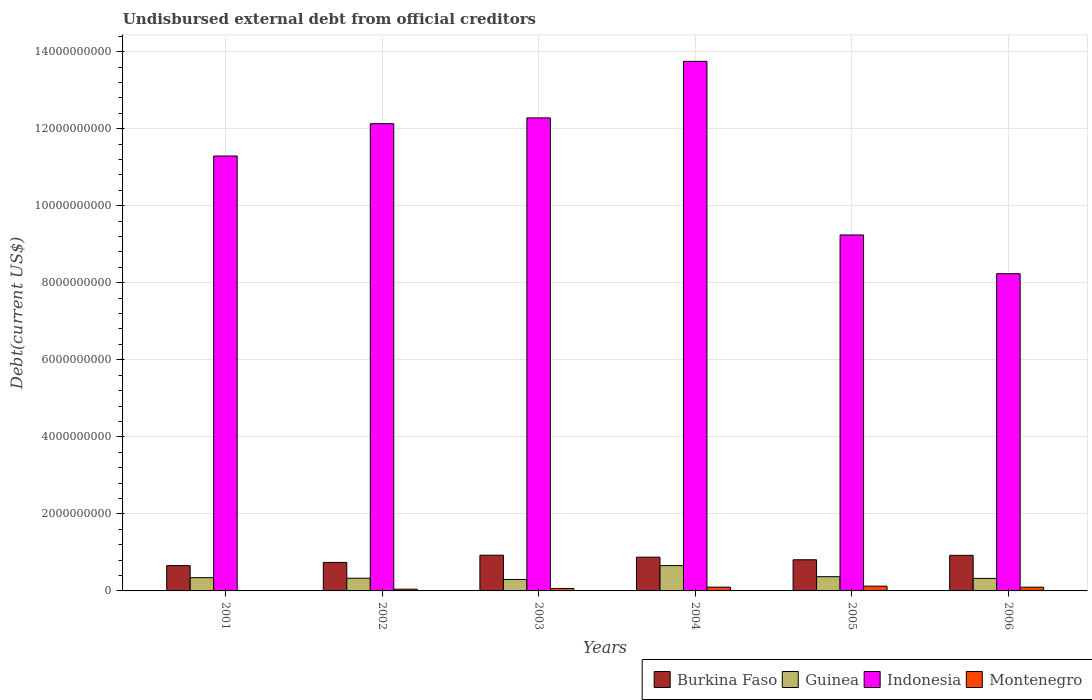How many groups of bars are there?
Provide a succinct answer. 6. How many bars are there on the 2nd tick from the left?
Your response must be concise. 4. What is the total debt in Montenegro in 2004?
Provide a succinct answer. 9.81e+07. Across all years, what is the maximum total debt in Guinea?
Keep it short and to the point. 6.57e+08. Across all years, what is the minimum total debt in Indonesia?
Offer a very short reply. 8.23e+09. What is the total total debt in Burkina Faso in the graph?
Provide a short and direct response. 4.93e+09. What is the difference between the total debt in Burkina Faso in 2003 and that in 2004?
Provide a succinct answer. 5.16e+07. What is the difference between the total debt in Montenegro in 2005 and the total debt in Indonesia in 2006?
Offer a terse response. -8.11e+09. What is the average total debt in Montenegro per year?
Ensure brevity in your answer.  7.28e+07. In the year 2001, what is the difference between the total debt in Montenegro and total debt in Burkina Faso?
Provide a succinct answer. -6.48e+08. In how many years, is the total debt in Indonesia greater than 1200000000 US$?
Your response must be concise. 6. What is the ratio of the total debt in Guinea in 2003 to that in 2006?
Give a very brief answer. 0.92. Is the total debt in Indonesia in 2002 less than that in 2006?
Offer a terse response. No. What is the difference between the highest and the second highest total debt in Montenegro?
Your response must be concise. 2.58e+07. What is the difference between the highest and the lowest total debt in Montenegro?
Offer a terse response. 1.15e+08. Is the sum of the total debt in Indonesia in 2003 and 2004 greater than the maximum total debt in Burkina Faso across all years?
Ensure brevity in your answer.  Yes. Is it the case that in every year, the sum of the total debt in Indonesia and total debt in Burkina Faso is greater than the sum of total debt in Guinea and total debt in Montenegro?
Offer a terse response. Yes. What does the 2nd bar from the left in 2005 represents?
Give a very brief answer. Guinea. Are all the bars in the graph horizontal?
Offer a terse response. No. How many years are there in the graph?
Provide a succinct answer. 6. What is the difference between two consecutive major ticks on the Y-axis?
Provide a succinct answer. 2.00e+09. Does the graph contain grids?
Keep it short and to the point. Yes. What is the title of the graph?
Provide a short and direct response. Undisbursed external debt from official creditors. What is the label or title of the Y-axis?
Provide a succinct answer. Debt(current US$). What is the Debt(current US$) of Burkina Faso in 2001?
Your answer should be very brief. 6.57e+08. What is the Debt(current US$) of Guinea in 2001?
Give a very brief answer. 3.44e+08. What is the Debt(current US$) of Indonesia in 2001?
Your answer should be compact. 1.13e+1. What is the Debt(current US$) of Montenegro in 2001?
Provide a short and direct response. 8.90e+06. What is the Debt(current US$) in Burkina Faso in 2002?
Provide a succinct answer. 7.40e+08. What is the Debt(current US$) of Guinea in 2002?
Ensure brevity in your answer.  3.30e+08. What is the Debt(current US$) of Indonesia in 2002?
Make the answer very short. 1.21e+1. What is the Debt(current US$) in Montenegro in 2002?
Your response must be concise. 4.53e+07. What is the Debt(current US$) of Burkina Faso in 2003?
Ensure brevity in your answer.  9.27e+08. What is the Debt(current US$) in Guinea in 2003?
Ensure brevity in your answer.  2.98e+08. What is the Debt(current US$) in Indonesia in 2003?
Your answer should be very brief. 1.23e+1. What is the Debt(current US$) of Montenegro in 2003?
Your response must be concise. 6.38e+07. What is the Debt(current US$) in Burkina Faso in 2004?
Give a very brief answer. 8.76e+08. What is the Debt(current US$) in Guinea in 2004?
Provide a short and direct response. 6.57e+08. What is the Debt(current US$) of Indonesia in 2004?
Your answer should be compact. 1.37e+1. What is the Debt(current US$) in Montenegro in 2004?
Your response must be concise. 9.81e+07. What is the Debt(current US$) of Burkina Faso in 2005?
Offer a very short reply. 8.08e+08. What is the Debt(current US$) in Guinea in 2005?
Offer a terse response. 3.70e+08. What is the Debt(current US$) in Indonesia in 2005?
Offer a very short reply. 9.24e+09. What is the Debt(current US$) in Montenegro in 2005?
Make the answer very short. 1.24e+08. What is the Debt(current US$) of Burkina Faso in 2006?
Provide a succinct answer. 9.24e+08. What is the Debt(current US$) in Guinea in 2006?
Offer a very short reply. 3.25e+08. What is the Debt(current US$) in Indonesia in 2006?
Your answer should be compact. 8.23e+09. What is the Debt(current US$) of Montenegro in 2006?
Ensure brevity in your answer.  9.70e+07. Across all years, what is the maximum Debt(current US$) of Burkina Faso?
Provide a short and direct response. 9.27e+08. Across all years, what is the maximum Debt(current US$) of Guinea?
Your answer should be compact. 6.57e+08. Across all years, what is the maximum Debt(current US$) of Indonesia?
Ensure brevity in your answer.  1.37e+1. Across all years, what is the maximum Debt(current US$) in Montenegro?
Offer a very short reply. 1.24e+08. Across all years, what is the minimum Debt(current US$) in Burkina Faso?
Provide a short and direct response. 6.57e+08. Across all years, what is the minimum Debt(current US$) of Guinea?
Keep it short and to the point. 2.98e+08. Across all years, what is the minimum Debt(current US$) of Indonesia?
Make the answer very short. 8.23e+09. Across all years, what is the minimum Debt(current US$) of Montenegro?
Make the answer very short. 8.90e+06. What is the total Debt(current US$) of Burkina Faso in the graph?
Keep it short and to the point. 4.93e+09. What is the total Debt(current US$) of Guinea in the graph?
Your answer should be very brief. 2.32e+09. What is the total Debt(current US$) in Indonesia in the graph?
Give a very brief answer. 6.69e+1. What is the total Debt(current US$) in Montenegro in the graph?
Make the answer very short. 4.37e+08. What is the difference between the Debt(current US$) of Burkina Faso in 2001 and that in 2002?
Ensure brevity in your answer.  -8.28e+07. What is the difference between the Debt(current US$) in Guinea in 2001 and that in 2002?
Make the answer very short. 1.46e+07. What is the difference between the Debt(current US$) in Indonesia in 2001 and that in 2002?
Offer a terse response. -8.39e+08. What is the difference between the Debt(current US$) in Montenegro in 2001 and that in 2002?
Keep it short and to the point. -3.64e+07. What is the difference between the Debt(current US$) in Burkina Faso in 2001 and that in 2003?
Your answer should be compact. -2.71e+08. What is the difference between the Debt(current US$) in Guinea in 2001 and that in 2003?
Your answer should be very brief. 4.65e+07. What is the difference between the Debt(current US$) in Indonesia in 2001 and that in 2003?
Give a very brief answer. -9.89e+08. What is the difference between the Debt(current US$) of Montenegro in 2001 and that in 2003?
Your answer should be compact. -5.49e+07. What is the difference between the Debt(current US$) in Burkina Faso in 2001 and that in 2004?
Your response must be concise. -2.19e+08. What is the difference between the Debt(current US$) in Guinea in 2001 and that in 2004?
Provide a short and direct response. -3.13e+08. What is the difference between the Debt(current US$) in Indonesia in 2001 and that in 2004?
Offer a very short reply. -2.46e+09. What is the difference between the Debt(current US$) in Montenegro in 2001 and that in 2004?
Your answer should be compact. -8.92e+07. What is the difference between the Debt(current US$) of Burkina Faso in 2001 and that in 2005?
Give a very brief answer. -1.52e+08. What is the difference between the Debt(current US$) in Guinea in 2001 and that in 2005?
Offer a very short reply. -2.57e+07. What is the difference between the Debt(current US$) of Indonesia in 2001 and that in 2005?
Your answer should be compact. 2.05e+09. What is the difference between the Debt(current US$) in Montenegro in 2001 and that in 2005?
Provide a succinct answer. -1.15e+08. What is the difference between the Debt(current US$) in Burkina Faso in 2001 and that in 2006?
Offer a very short reply. -2.67e+08. What is the difference between the Debt(current US$) in Guinea in 2001 and that in 2006?
Provide a short and direct response. 1.91e+07. What is the difference between the Debt(current US$) in Indonesia in 2001 and that in 2006?
Your answer should be very brief. 3.06e+09. What is the difference between the Debt(current US$) of Montenegro in 2001 and that in 2006?
Offer a terse response. -8.81e+07. What is the difference between the Debt(current US$) of Burkina Faso in 2002 and that in 2003?
Provide a succinct answer. -1.88e+08. What is the difference between the Debt(current US$) in Guinea in 2002 and that in 2003?
Your answer should be compact. 3.19e+07. What is the difference between the Debt(current US$) of Indonesia in 2002 and that in 2003?
Your response must be concise. -1.50e+08. What is the difference between the Debt(current US$) of Montenegro in 2002 and that in 2003?
Your answer should be very brief. -1.85e+07. What is the difference between the Debt(current US$) in Burkina Faso in 2002 and that in 2004?
Offer a terse response. -1.36e+08. What is the difference between the Debt(current US$) in Guinea in 2002 and that in 2004?
Ensure brevity in your answer.  -3.27e+08. What is the difference between the Debt(current US$) in Indonesia in 2002 and that in 2004?
Your answer should be compact. -1.62e+09. What is the difference between the Debt(current US$) of Montenegro in 2002 and that in 2004?
Your answer should be compact. -5.28e+07. What is the difference between the Debt(current US$) in Burkina Faso in 2002 and that in 2005?
Make the answer very short. -6.89e+07. What is the difference between the Debt(current US$) of Guinea in 2002 and that in 2005?
Make the answer very short. -4.03e+07. What is the difference between the Debt(current US$) of Indonesia in 2002 and that in 2005?
Keep it short and to the point. 2.89e+09. What is the difference between the Debt(current US$) of Montenegro in 2002 and that in 2005?
Offer a terse response. -7.86e+07. What is the difference between the Debt(current US$) in Burkina Faso in 2002 and that in 2006?
Offer a very short reply. -1.84e+08. What is the difference between the Debt(current US$) of Guinea in 2002 and that in 2006?
Provide a short and direct response. 4.50e+06. What is the difference between the Debt(current US$) in Indonesia in 2002 and that in 2006?
Provide a short and direct response. 3.89e+09. What is the difference between the Debt(current US$) in Montenegro in 2002 and that in 2006?
Provide a short and direct response. -5.17e+07. What is the difference between the Debt(current US$) of Burkina Faso in 2003 and that in 2004?
Your response must be concise. 5.16e+07. What is the difference between the Debt(current US$) of Guinea in 2003 and that in 2004?
Make the answer very short. -3.59e+08. What is the difference between the Debt(current US$) of Indonesia in 2003 and that in 2004?
Provide a succinct answer. -1.47e+09. What is the difference between the Debt(current US$) of Montenegro in 2003 and that in 2004?
Offer a terse response. -3.43e+07. What is the difference between the Debt(current US$) of Burkina Faso in 2003 and that in 2005?
Give a very brief answer. 1.19e+08. What is the difference between the Debt(current US$) of Guinea in 2003 and that in 2005?
Give a very brief answer. -7.22e+07. What is the difference between the Debt(current US$) of Indonesia in 2003 and that in 2005?
Offer a terse response. 3.04e+09. What is the difference between the Debt(current US$) in Montenegro in 2003 and that in 2005?
Give a very brief answer. -6.01e+07. What is the difference between the Debt(current US$) of Burkina Faso in 2003 and that in 2006?
Offer a terse response. 3.61e+06. What is the difference between the Debt(current US$) in Guinea in 2003 and that in 2006?
Provide a short and direct response. -2.74e+07. What is the difference between the Debt(current US$) of Indonesia in 2003 and that in 2006?
Offer a very short reply. 4.04e+09. What is the difference between the Debt(current US$) in Montenegro in 2003 and that in 2006?
Give a very brief answer. -3.32e+07. What is the difference between the Debt(current US$) of Burkina Faso in 2004 and that in 2005?
Your answer should be very brief. 6.74e+07. What is the difference between the Debt(current US$) of Guinea in 2004 and that in 2005?
Keep it short and to the point. 2.87e+08. What is the difference between the Debt(current US$) of Indonesia in 2004 and that in 2005?
Your response must be concise. 4.51e+09. What is the difference between the Debt(current US$) in Montenegro in 2004 and that in 2005?
Keep it short and to the point. -2.58e+07. What is the difference between the Debt(current US$) of Burkina Faso in 2004 and that in 2006?
Keep it short and to the point. -4.80e+07. What is the difference between the Debt(current US$) of Guinea in 2004 and that in 2006?
Keep it short and to the point. 3.32e+08. What is the difference between the Debt(current US$) of Indonesia in 2004 and that in 2006?
Provide a short and direct response. 5.51e+09. What is the difference between the Debt(current US$) of Montenegro in 2004 and that in 2006?
Provide a succinct answer. 1.08e+06. What is the difference between the Debt(current US$) of Burkina Faso in 2005 and that in 2006?
Provide a succinct answer. -1.15e+08. What is the difference between the Debt(current US$) in Guinea in 2005 and that in 2006?
Your answer should be compact. 4.48e+07. What is the difference between the Debt(current US$) of Indonesia in 2005 and that in 2006?
Ensure brevity in your answer.  1.01e+09. What is the difference between the Debt(current US$) of Montenegro in 2005 and that in 2006?
Ensure brevity in your answer.  2.69e+07. What is the difference between the Debt(current US$) of Burkina Faso in 2001 and the Debt(current US$) of Guinea in 2002?
Your answer should be very brief. 3.27e+08. What is the difference between the Debt(current US$) in Burkina Faso in 2001 and the Debt(current US$) in Indonesia in 2002?
Your answer should be compact. -1.15e+1. What is the difference between the Debt(current US$) of Burkina Faso in 2001 and the Debt(current US$) of Montenegro in 2002?
Give a very brief answer. 6.11e+08. What is the difference between the Debt(current US$) in Guinea in 2001 and the Debt(current US$) in Indonesia in 2002?
Keep it short and to the point. -1.18e+1. What is the difference between the Debt(current US$) in Guinea in 2001 and the Debt(current US$) in Montenegro in 2002?
Offer a terse response. 2.99e+08. What is the difference between the Debt(current US$) in Indonesia in 2001 and the Debt(current US$) in Montenegro in 2002?
Offer a very short reply. 1.12e+1. What is the difference between the Debt(current US$) in Burkina Faso in 2001 and the Debt(current US$) in Guinea in 2003?
Offer a very short reply. 3.59e+08. What is the difference between the Debt(current US$) in Burkina Faso in 2001 and the Debt(current US$) in Indonesia in 2003?
Make the answer very short. -1.16e+1. What is the difference between the Debt(current US$) of Burkina Faso in 2001 and the Debt(current US$) of Montenegro in 2003?
Provide a succinct answer. 5.93e+08. What is the difference between the Debt(current US$) of Guinea in 2001 and the Debt(current US$) of Indonesia in 2003?
Your answer should be compact. -1.19e+1. What is the difference between the Debt(current US$) in Guinea in 2001 and the Debt(current US$) in Montenegro in 2003?
Give a very brief answer. 2.80e+08. What is the difference between the Debt(current US$) of Indonesia in 2001 and the Debt(current US$) of Montenegro in 2003?
Offer a very short reply. 1.12e+1. What is the difference between the Debt(current US$) of Burkina Faso in 2001 and the Debt(current US$) of Guinea in 2004?
Give a very brief answer. -6.40e+04. What is the difference between the Debt(current US$) in Burkina Faso in 2001 and the Debt(current US$) in Indonesia in 2004?
Provide a short and direct response. -1.31e+1. What is the difference between the Debt(current US$) of Burkina Faso in 2001 and the Debt(current US$) of Montenegro in 2004?
Provide a succinct answer. 5.59e+08. What is the difference between the Debt(current US$) of Guinea in 2001 and the Debt(current US$) of Indonesia in 2004?
Your answer should be very brief. -1.34e+1. What is the difference between the Debt(current US$) of Guinea in 2001 and the Debt(current US$) of Montenegro in 2004?
Provide a succinct answer. 2.46e+08. What is the difference between the Debt(current US$) of Indonesia in 2001 and the Debt(current US$) of Montenegro in 2004?
Give a very brief answer. 1.12e+1. What is the difference between the Debt(current US$) of Burkina Faso in 2001 and the Debt(current US$) of Guinea in 2005?
Provide a short and direct response. 2.87e+08. What is the difference between the Debt(current US$) in Burkina Faso in 2001 and the Debt(current US$) in Indonesia in 2005?
Keep it short and to the point. -8.58e+09. What is the difference between the Debt(current US$) in Burkina Faso in 2001 and the Debt(current US$) in Montenegro in 2005?
Make the answer very short. 5.33e+08. What is the difference between the Debt(current US$) in Guinea in 2001 and the Debt(current US$) in Indonesia in 2005?
Provide a succinct answer. -8.90e+09. What is the difference between the Debt(current US$) of Guinea in 2001 and the Debt(current US$) of Montenegro in 2005?
Give a very brief answer. 2.20e+08. What is the difference between the Debt(current US$) in Indonesia in 2001 and the Debt(current US$) in Montenegro in 2005?
Give a very brief answer. 1.12e+1. What is the difference between the Debt(current US$) of Burkina Faso in 2001 and the Debt(current US$) of Guinea in 2006?
Make the answer very short. 3.32e+08. What is the difference between the Debt(current US$) in Burkina Faso in 2001 and the Debt(current US$) in Indonesia in 2006?
Provide a short and direct response. -7.58e+09. What is the difference between the Debt(current US$) of Burkina Faso in 2001 and the Debt(current US$) of Montenegro in 2006?
Your answer should be very brief. 5.60e+08. What is the difference between the Debt(current US$) in Guinea in 2001 and the Debt(current US$) in Indonesia in 2006?
Your answer should be compact. -7.89e+09. What is the difference between the Debt(current US$) of Guinea in 2001 and the Debt(current US$) of Montenegro in 2006?
Offer a terse response. 2.47e+08. What is the difference between the Debt(current US$) of Indonesia in 2001 and the Debt(current US$) of Montenegro in 2006?
Offer a terse response. 1.12e+1. What is the difference between the Debt(current US$) in Burkina Faso in 2002 and the Debt(current US$) in Guinea in 2003?
Provide a succinct answer. 4.42e+08. What is the difference between the Debt(current US$) in Burkina Faso in 2002 and the Debt(current US$) in Indonesia in 2003?
Keep it short and to the point. -1.15e+1. What is the difference between the Debt(current US$) in Burkina Faso in 2002 and the Debt(current US$) in Montenegro in 2003?
Offer a terse response. 6.76e+08. What is the difference between the Debt(current US$) of Guinea in 2002 and the Debt(current US$) of Indonesia in 2003?
Provide a short and direct response. -1.19e+1. What is the difference between the Debt(current US$) of Guinea in 2002 and the Debt(current US$) of Montenegro in 2003?
Your answer should be very brief. 2.66e+08. What is the difference between the Debt(current US$) in Indonesia in 2002 and the Debt(current US$) in Montenegro in 2003?
Offer a terse response. 1.21e+1. What is the difference between the Debt(current US$) in Burkina Faso in 2002 and the Debt(current US$) in Guinea in 2004?
Provide a short and direct response. 8.27e+07. What is the difference between the Debt(current US$) in Burkina Faso in 2002 and the Debt(current US$) in Indonesia in 2004?
Give a very brief answer. -1.30e+1. What is the difference between the Debt(current US$) in Burkina Faso in 2002 and the Debt(current US$) in Montenegro in 2004?
Provide a succinct answer. 6.41e+08. What is the difference between the Debt(current US$) in Guinea in 2002 and the Debt(current US$) in Indonesia in 2004?
Your answer should be compact. -1.34e+1. What is the difference between the Debt(current US$) of Guinea in 2002 and the Debt(current US$) of Montenegro in 2004?
Your answer should be very brief. 2.31e+08. What is the difference between the Debt(current US$) of Indonesia in 2002 and the Debt(current US$) of Montenegro in 2004?
Offer a terse response. 1.20e+1. What is the difference between the Debt(current US$) in Burkina Faso in 2002 and the Debt(current US$) in Guinea in 2005?
Ensure brevity in your answer.  3.70e+08. What is the difference between the Debt(current US$) of Burkina Faso in 2002 and the Debt(current US$) of Indonesia in 2005?
Offer a terse response. -8.50e+09. What is the difference between the Debt(current US$) in Burkina Faso in 2002 and the Debt(current US$) in Montenegro in 2005?
Make the answer very short. 6.16e+08. What is the difference between the Debt(current US$) of Guinea in 2002 and the Debt(current US$) of Indonesia in 2005?
Offer a terse response. -8.91e+09. What is the difference between the Debt(current US$) of Guinea in 2002 and the Debt(current US$) of Montenegro in 2005?
Your response must be concise. 2.06e+08. What is the difference between the Debt(current US$) in Indonesia in 2002 and the Debt(current US$) in Montenegro in 2005?
Your answer should be very brief. 1.20e+1. What is the difference between the Debt(current US$) of Burkina Faso in 2002 and the Debt(current US$) of Guinea in 2006?
Your answer should be compact. 4.14e+08. What is the difference between the Debt(current US$) in Burkina Faso in 2002 and the Debt(current US$) in Indonesia in 2006?
Make the answer very short. -7.50e+09. What is the difference between the Debt(current US$) of Burkina Faso in 2002 and the Debt(current US$) of Montenegro in 2006?
Provide a succinct answer. 6.43e+08. What is the difference between the Debt(current US$) in Guinea in 2002 and the Debt(current US$) in Indonesia in 2006?
Your response must be concise. -7.91e+09. What is the difference between the Debt(current US$) in Guinea in 2002 and the Debt(current US$) in Montenegro in 2006?
Give a very brief answer. 2.33e+08. What is the difference between the Debt(current US$) of Indonesia in 2002 and the Debt(current US$) of Montenegro in 2006?
Keep it short and to the point. 1.20e+1. What is the difference between the Debt(current US$) of Burkina Faso in 2003 and the Debt(current US$) of Guinea in 2004?
Make the answer very short. 2.71e+08. What is the difference between the Debt(current US$) in Burkina Faso in 2003 and the Debt(current US$) in Indonesia in 2004?
Offer a terse response. -1.28e+1. What is the difference between the Debt(current US$) in Burkina Faso in 2003 and the Debt(current US$) in Montenegro in 2004?
Offer a very short reply. 8.29e+08. What is the difference between the Debt(current US$) of Guinea in 2003 and the Debt(current US$) of Indonesia in 2004?
Provide a short and direct response. -1.34e+1. What is the difference between the Debt(current US$) in Guinea in 2003 and the Debt(current US$) in Montenegro in 2004?
Offer a very short reply. 2.00e+08. What is the difference between the Debt(current US$) in Indonesia in 2003 and the Debt(current US$) in Montenegro in 2004?
Make the answer very short. 1.22e+1. What is the difference between the Debt(current US$) of Burkina Faso in 2003 and the Debt(current US$) of Guinea in 2005?
Give a very brief answer. 5.58e+08. What is the difference between the Debt(current US$) in Burkina Faso in 2003 and the Debt(current US$) in Indonesia in 2005?
Offer a terse response. -8.31e+09. What is the difference between the Debt(current US$) in Burkina Faso in 2003 and the Debt(current US$) in Montenegro in 2005?
Your response must be concise. 8.04e+08. What is the difference between the Debt(current US$) of Guinea in 2003 and the Debt(current US$) of Indonesia in 2005?
Offer a very short reply. -8.94e+09. What is the difference between the Debt(current US$) of Guinea in 2003 and the Debt(current US$) of Montenegro in 2005?
Offer a terse response. 1.74e+08. What is the difference between the Debt(current US$) in Indonesia in 2003 and the Debt(current US$) in Montenegro in 2005?
Keep it short and to the point. 1.22e+1. What is the difference between the Debt(current US$) in Burkina Faso in 2003 and the Debt(current US$) in Guinea in 2006?
Keep it short and to the point. 6.02e+08. What is the difference between the Debt(current US$) in Burkina Faso in 2003 and the Debt(current US$) in Indonesia in 2006?
Provide a succinct answer. -7.31e+09. What is the difference between the Debt(current US$) in Burkina Faso in 2003 and the Debt(current US$) in Montenegro in 2006?
Give a very brief answer. 8.30e+08. What is the difference between the Debt(current US$) of Guinea in 2003 and the Debt(current US$) of Indonesia in 2006?
Your answer should be compact. -7.94e+09. What is the difference between the Debt(current US$) in Guinea in 2003 and the Debt(current US$) in Montenegro in 2006?
Your response must be concise. 2.01e+08. What is the difference between the Debt(current US$) in Indonesia in 2003 and the Debt(current US$) in Montenegro in 2006?
Offer a very short reply. 1.22e+1. What is the difference between the Debt(current US$) of Burkina Faso in 2004 and the Debt(current US$) of Guinea in 2005?
Ensure brevity in your answer.  5.06e+08. What is the difference between the Debt(current US$) in Burkina Faso in 2004 and the Debt(current US$) in Indonesia in 2005?
Keep it short and to the point. -8.36e+09. What is the difference between the Debt(current US$) of Burkina Faso in 2004 and the Debt(current US$) of Montenegro in 2005?
Give a very brief answer. 7.52e+08. What is the difference between the Debt(current US$) in Guinea in 2004 and the Debt(current US$) in Indonesia in 2005?
Keep it short and to the point. -8.58e+09. What is the difference between the Debt(current US$) of Guinea in 2004 and the Debt(current US$) of Montenegro in 2005?
Provide a succinct answer. 5.33e+08. What is the difference between the Debt(current US$) of Indonesia in 2004 and the Debt(current US$) of Montenegro in 2005?
Keep it short and to the point. 1.36e+1. What is the difference between the Debt(current US$) in Burkina Faso in 2004 and the Debt(current US$) in Guinea in 2006?
Your response must be concise. 5.51e+08. What is the difference between the Debt(current US$) of Burkina Faso in 2004 and the Debt(current US$) of Indonesia in 2006?
Ensure brevity in your answer.  -7.36e+09. What is the difference between the Debt(current US$) in Burkina Faso in 2004 and the Debt(current US$) in Montenegro in 2006?
Ensure brevity in your answer.  7.79e+08. What is the difference between the Debt(current US$) of Guinea in 2004 and the Debt(current US$) of Indonesia in 2006?
Offer a terse response. -7.58e+09. What is the difference between the Debt(current US$) in Guinea in 2004 and the Debt(current US$) in Montenegro in 2006?
Ensure brevity in your answer.  5.60e+08. What is the difference between the Debt(current US$) in Indonesia in 2004 and the Debt(current US$) in Montenegro in 2006?
Give a very brief answer. 1.36e+1. What is the difference between the Debt(current US$) in Burkina Faso in 2005 and the Debt(current US$) in Guinea in 2006?
Provide a short and direct response. 4.83e+08. What is the difference between the Debt(current US$) of Burkina Faso in 2005 and the Debt(current US$) of Indonesia in 2006?
Your answer should be very brief. -7.43e+09. What is the difference between the Debt(current US$) of Burkina Faso in 2005 and the Debt(current US$) of Montenegro in 2006?
Make the answer very short. 7.11e+08. What is the difference between the Debt(current US$) in Guinea in 2005 and the Debt(current US$) in Indonesia in 2006?
Provide a succinct answer. -7.86e+09. What is the difference between the Debt(current US$) in Guinea in 2005 and the Debt(current US$) in Montenegro in 2006?
Offer a terse response. 2.73e+08. What is the difference between the Debt(current US$) of Indonesia in 2005 and the Debt(current US$) of Montenegro in 2006?
Provide a succinct answer. 9.14e+09. What is the average Debt(current US$) of Burkina Faso per year?
Ensure brevity in your answer.  8.22e+08. What is the average Debt(current US$) in Guinea per year?
Your answer should be compact. 3.87e+08. What is the average Debt(current US$) of Indonesia per year?
Give a very brief answer. 1.12e+1. What is the average Debt(current US$) in Montenegro per year?
Offer a very short reply. 7.28e+07. In the year 2001, what is the difference between the Debt(current US$) in Burkina Faso and Debt(current US$) in Guinea?
Offer a very short reply. 3.13e+08. In the year 2001, what is the difference between the Debt(current US$) of Burkina Faso and Debt(current US$) of Indonesia?
Give a very brief answer. -1.06e+1. In the year 2001, what is the difference between the Debt(current US$) of Burkina Faso and Debt(current US$) of Montenegro?
Your answer should be compact. 6.48e+08. In the year 2001, what is the difference between the Debt(current US$) of Guinea and Debt(current US$) of Indonesia?
Provide a succinct answer. -1.09e+1. In the year 2001, what is the difference between the Debt(current US$) of Guinea and Debt(current US$) of Montenegro?
Provide a succinct answer. 3.35e+08. In the year 2001, what is the difference between the Debt(current US$) in Indonesia and Debt(current US$) in Montenegro?
Offer a very short reply. 1.13e+1. In the year 2002, what is the difference between the Debt(current US$) in Burkina Faso and Debt(current US$) in Guinea?
Make the answer very short. 4.10e+08. In the year 2002, what is the difference between the Debt(current US$) in Burkina Faso and Debt(current US$) in Indonesia?
Provide a short and direct response. -1.14e+1. In the year 2002, what is the difference between the Debt(current US$) of Burkina Faso and Debt(current US$) of Montenegro?
Provide a short and direct response. 6.94e+08. In the year 2002, what is the difference between the Debt(current US$) in Guinea and Debt(current US$) in Indonesia?
Offer a terse response. -1.18e+1. In the year 2002, what is the difference between the Debt(current US$) in Guinea and Debt(current US$) in Montenegro?
Offer a very short reply. 2.84e+08. In the year 2002, what is the difference between the Debt(current US$) of Indonesia and Debt(current US$) of Montenegro?
Give a very brief answer. 1.21e+1. In the year 2003, what is the difference between the Debt(current US$) of Burkina Faso and Debt(current US$) of Guinea?
Your answer should be very brief. 6.30e+08. In the year 2003, what is the difference between the Debt(current US$) of Burkina Faso and Debt(current US$) of Indonesia?
Give a very brief answer. -1.14e+1. In the year 2003, what is the difference between the Debt(current US$) of Burkina Faso and Debt(current US$) of Montenegro?
Your answer should be compact. 8.64e+08. In the year 2003, what is the difference between the Debt(current US$) in Guinea and Debt(current US$) in Indonesia?
Your answer should be very brief. -1.20e+1. In the year 2003, what is the difference between the Debt(current US$) in Guinea and Debt(current US$) in Montenegro?
Ensure brevity in your answer.  2.34e+08. In the year 2003, what is the difference between the Debt(current US$) of Indonesia and Debt(current US$) of Montenegro?
Keep it short and to the point. 1.22e+1. In the year 2004, what is the difference between the Debt(current US$) of Burkina Faso and Debt(current US$) of Guinea?
Give a very brief answer. 2.19e+08. In the year 2004, what is the difference between the Debt(current US$) of Burkina Faso and Debt(current US$) of Indonesia?
Offer a terse response. -1.29e+1. In the year 2004, what is the difference between the Debt(current US$) of Burkina Faso and Debt(current US$) of Montenegro?
Make the answer very short. 7.78e+08. In the year 2004, what is the difference between the Debt(current US$) in Guinea and Debt(current US$) in Indonesia?
Make the answer very short. -1.31e+1. In the year 2004, what is the difference between the Debt(current US$) in Guinea and Debt(current US$) in Montenegro?
Offer a very short reply. 5.59e+08. In the year 2004, what is the difference between the Debt(current US$) in Indonesia and Debt(current US$) in Montenegro?
Your answer should be very brief. 1.36e+1. In the year 2005, what is the difference between the Debt(current US$) of Burkina Faso and Debt(current US$) of Guinea?
Make the answer very short. 4.38e+08. In the year 2005, what is the difference between the Debt(current US$) of Burkina Faso and Debt(current US$) of Indonesia?
Your answer should be very brief. -8.43e+09. In the year 2005, what is the difference between the Debt(current US$) of Burkina Faso and Debt(current US$) of Montenegro?
Offer a very short reply. 6.84e+08. In the year 2005, what is the difference between the Debt(current US$) in Guinea and Debt(current US$) in Indonesia?
Offer a very short reply. -8.87e+09. In the year 2005, what is the difference between the Debt(current US$) in Guinea and Debt(current US$) in Montenegro?
Provide a short and direct response. 2.46e+08. In the year 2005, what is the difference between the Debt(current US$) of Indonesia and Debt(current US$) of Montenegro?
Your response must be concise. 9.12e+09. In the year 2006, what is the difference between the Debt(current US$) in Burkina Faso and Debt(current US$) in Guinea?
Give a very brief answer. 5.99e+08. In the year 2006, what is the difference between the Debt(current US$) in Burkina Faso and Debt(current US$) in Indonesia?
Make the answer very short. -7.31e+09. In the year 2006, what is the difference between the Debt(current US$) in Burkina Faso and Debt(current US$) in Montenegro?
Your response must be concise. 8.27e+08. In the year 2006, what is the difference between the Debt(current US$) in Guinea and Debt(current US$) in Indonesia?
Provide a short and direct response. -7.91e+09. In the year 2006, what is the difference between the Debt(current US$) in Guinea and Debt(current US$) in Montenegro?
Your answer should be very brief. 2.28e+08. In the year 2006, what is the difference between the Debt(current US$) in Indonesia and Debt(current US$) in Montenegro?
Provide a succinct answer. 8.14e+09. What is the ratio of the Debt(current US$) of Burkina Faso in 2001 to that in 2002?
Your answer should be very brief. 0.89. What is the ratio of the Debt(current US$) in Guinea in 2001 to that in 2002?
Your answer should be compact. 1.04. What is the ratio of the Debt(current US$) in Indonesia in 2001 to that in 2002?
Your response must be concise. 0.93. What is the ratio of the Debt(current US$) of Montenegro in 2001 to that in 2002?
Offer a terse response. 0.2. What is the ratio of the Debt(current US$) of Burkina Faso in 2001 to that in 2003?
Your response must be concise. 0.71. What is the ratio of the Debt(current US$) of Guinea in 2001 to that in 2003?
Your answer should be very brief. 1.16. What is the ratio of the Debt(current US$) of Indonesia in 2001 to that in 2003?
Your answer should be very brief. 0.92. What is the ratio of the Debt(current US$) of Montenegro in 2001 to that in 2003?
Your answer should be compact. 0.14. What is the ratio of the Debt(current US$) of Burkina Faso in 2001 to that in 2004?
Keep it short and to the point. 0.75. What is the ratio of the Debt(current US$) in Guinea in 2001 to that in 2004?
Provide a short and direct response. 0.52. What is the ratio of the Debt(current US$) of Indonesia in 2001 to that in 2004?
Your answer should be very brief. 0.82. What is the ratio of the Debt(current US$) of Montenegro in 2001 to that in 2004?
Provide a short and direct response. 0.09. What is the ratio of the Debt(current US$) in Burkina Faso in 2001 to that in 2005?
Give a very brief answer. 0.81. What is the ratio of the Debt(current US$) in Guinea in 2001 to that in 2005?
Keep it short and to the point. 0.93. What is the ratio of the Debt(current US$) in Indonesia in 2001 to that in 2005?
Give a very brief answer. 1.22. What is the ratio of the Debt(current US$) in Montenegro in 2001 to that in 2005?
Provide a short and direct response. 0.07. What is the ratio of the Debt(current US$) in Burkina Faso in 2001 to that in 2006?
Your answer should be very brief. 0.71. What is the ratio of the Debt(current US$) in Guinea in 2001 to that in 2006?
Provide a short and direct response. 1.06. What is the ratio of the Debt(current US$) in Indonesia in 2001 to that in 2006?
Your answer should be compact. 1.37. What is the ratio of the Debt(current US$) in Montenegro in 2001 to that in 2006?
Make the answer very short. 0.09. What is the ratio of the Debt(current US$) in Burkina Faso in 2002 to that in 2003?
Provide a succinct answer. 0.8. What is the ratio of the Debt(current US$) in Guinea in 2002 to that in 2003?
Your answer should be very brief. 1.11. What is the ratio of the Debt(current US$) in Indonesia in 2002 to that in 2003?
Keep it short and to the point. 0.99. What is the ratio of the Debt(current US$) in Montenegro in 2002 to that in 2003?
Offer a terse response. 0.71. What is the ratio of the Debt(current US$) in Burkina Faso in 2002 to that in 2004?
Your response must be concise. 0.84. What is the ratio of the Debt(current US$) in Guinea in 2002 to that in 2004?
Offer a terse response. 0.5. What is the ratio of the Debt(current US$) in Indonesia in 2002 to that in 2004?
Provide a succinct answer. 0.88. What is the ratio of the Debt(current US$) of Montenegro in 2002 to that in 2004?
Your answer should be very brief. 0.46. What is the ratio of the Debt(current US$) of Burkina Faso in 2002 to that in 2005?
Your answer should be very brief. 0.91. What is the ratio of the Debt(current US$) of Guinea in 2002 to that in 2005?
Your answer should be compact. 0.89. What is the ratio of the Debt(current US$) in Indonesia in 2002 to that in 2005?
Your response must be concise. 1.31. What is the ratio of the Debt(current US$) of Montenegro in 2002 to that in 2005?
Provide a short and direct response. 0.37. What is the ratio of the Debt(current US$) of Burkina Faso in 2002 to that in 2006?
Offer a very short reply. 0.8. What is the ratio of the Debt(current US$) of Guinea in 2002 to that in 2006?
Ensure brevity in your answer.  1.01. What is the ratio of the Debt(current US$) of Indonesia in 2002 to that in 2006?
Your answer should be very brief. 1.47. What is the ratio of the Debt(current US$) of Montenegro in 2002 to that in 2006?
Ensure brevity in your answer.  0.47. What is the ratio of the Debt(current US$) in Burkina Faso in 2003 to that in 2004?
Provide a short and direct response. 1.06. What is the ratio of the Debt(current US$) of Guinea in 2003 to that in 2004?
Offer a very short reply. 0.45. What is the ratio of the Debt(current US$) of Indonesia in 2003 to that in 2004?
Keep it short and to the point. 0.89. What is the ratio of the Debt(current US$) in Montenegro in 2003 to that in 2004?
Your answer should be very brief. 0.65. What is the ratio of the Debt(current US$) in Burkina Faso in 2003 to that in 2005?
Offer a terse response. 1.15. What is the ratio of the Debt(current US$) in Guinea in 2003 to that in 2005?
Provide a succinct answer. 0.8. What is the ratio of the Debt(current US$) of Indonesia in 2003 to that in 2005?
Keep it short and to the point. 1.33. What is the ratio of the Debt(current US$) of Montenegro in 2003 to that in 2005?
Provide a short and direct response. 0.51. What is the ratio of the Debt(current US$) in Burkina Faso in 2003 to that in 2006?
Offer a terse response. 1. What is the ratio of the Debt(current US$) in Guinea in 2003 to that in 2006?
Your answer should be compact. 0.92. What is the ratio of the Debt(current US$) of Indonesia in 2003 to that in 2006?
Offer a terse response. 1.49. What is the ratio of the Debt(current US$) of Montenegro in 2003 to that in 2006?
Ensure brevity in your answer.  0.66. What is the ratio of the Debt(current US$) in Burkina Faso in 2004 to that in 2005?
Give a very brief answer. 1.08. What is the ratio of the Debt(current US$) of Guinea in 2004 to that in 2005?
Offer a terse response. 1.78. What is the ratio of the Debt(current US$) in Indonesia in 2004 to that in 2005?
Offer a terse response. 1.49. What is the ratio of the Debt(current US$) of Montenegro in 2004 to that in 2005?
Your answer should be very brief. 0.79. What is the ratio of the Debt(current US$) in Burkina Faso in 2004 to that in 2006?
Offer a very short reply. 0.95. What is the ratio of the Debt(current US$) in Guinea in 2004 to that in 2006?
Provide a short and direct response. 2.02. What is the ratio of the Debt(current US$) in Indonesia in 2004 to that in 2006?
Provide a succinct answer. 1.67. What is the ratio of the Debt(current US$) in Montenegro in 2004 to that in 2006?
Provide a succinct answer. 1.01. What is the ratio of the Debt(current US$) of Burkina Faso in 2005 to that in 2006?
Offer a terse response. 0.88. What is the ratio of the Debt(current US$) of Guinea in 2005 to that in 2006?
Your answer should be very brief. 1.14. What is the ratio of the Debt(current US$) of Indonesia in 2005 to that in 2006?
Your answer should be compact. 1.12. What is the ratio of the Debt(current US$) of Montenegro in 2005 to that in 2006?
Provide a succinct answer. 1.28. What is the difference between the highest and the second highest Debt(current US$) of Burkina Faso?
Your answer should be very brief. 3.61e+06. What is the difference between the highest and the second highest Debt(current US$) of Guinea?
Your answer should be compact. 2.87e+08. What is the difference between the highest and the second highest Debt(current US$) of Indonesia?
Provide a short and direct response. 1.47e+09. What is the difference between the highest and the second highest Debt(current US$) of Montenegro?
Provide a succinct answer. 2.58e+07. What is the difference between the highest and the lowest Debt(current US$) of Burkina Faso?
Provide a succinct answer. 2.71e+08. What is the difference between the highest and the lowest Debt(current US$) in Guinea?
Your answer should be compact. 3.59e+08. What is the difference between the highest and the lowest Debt(current US$) of Indonesia?
Offer a very short reply. 5.51e+09. What is the difference between the highest and the lowest Debt(current US$) in Montenegro?
Ensure brevity in your answer.  1.15e+08. 